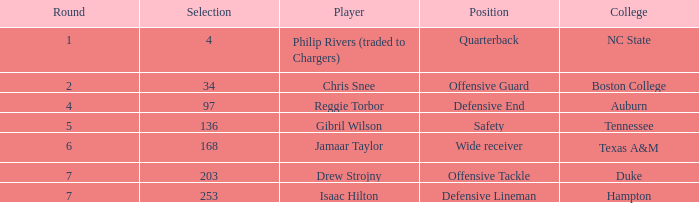Which position possesses a round exceeding 5, and an assortment of 168? Wide receiver. 